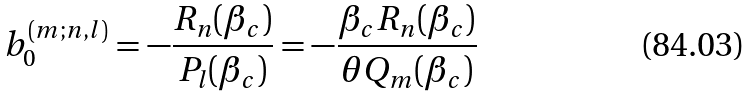Convert formula to latex. <formula><loc_0><loc_0><loc_500><loc_500>b _ { 0 } ^ { ( m ; n , l ) } = - \frac { R _ { n } ( \beta _ { c } ) } { P _ { l } ( \beta _ { c } ) } = - \frac { \beta _ { c } R _ { n } ( \beta _ { c } ) } { \theta Q _ { m } ( \beta _ { c } ) }</formula> 